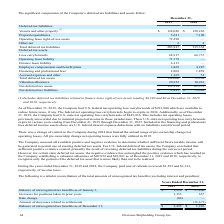From Overseas Shipholding Group's financial document, How much did the company paid (net of refunds received) of income taxes during the years ended December 31, 2019 and 2018 respectively? The document shows two values: $1,293 and $1,313. From the document: "d 2018, the Company paid (net of refunds received) $1,293 and $1,313, respectively, of income taxes. Company paid (net of refunds received) $1,293 and..." Also, can you calculate: What is the change in Net deferred tax liabilities from December 31, 2018 to 2019? Based on the calculation: 72,833-73,365, the result is -532. This is based on the information: "Net deferred tax liabilities $ 72,833 $ 73,365 Net deferred tax liabilities $ 72,833 $ 73,365..." The key data points involved are: 72,833, 73,365. Also, can you calculate: What is the average Net deferred tax liabilities for December 31, 2018 to 2019? To answer this question, I need to perform calculations using the financial data. The calculation is: (72,833+73,365) / 2, which equals 73099. This is based on the information: "Net deferred tax liabilities $ 72,833 $ 73,365 Net deferred tax liabilities $ 72,833 $ 73,365..." The key data points involved are: 72,833, 73,365. Additionally, In which year was Prepaid expenditures less than 6,000? According to the financial document, 2019. The relevant text states: "2019 2018..." Also, What was the Prepaid expenditures in 2019 and 2018 respectively? The document shows two values: 5,621 and 7,108. From the document: "Prepaid expenditures 5,621 7,108 Prepaid expenditures 5,621 7,108..." Also, What was the total deferred tax liabilities in 2019? According to the financial document, 205,947. The relevant text states: "Total deferred tax liabilities 205,947 135,338..." 